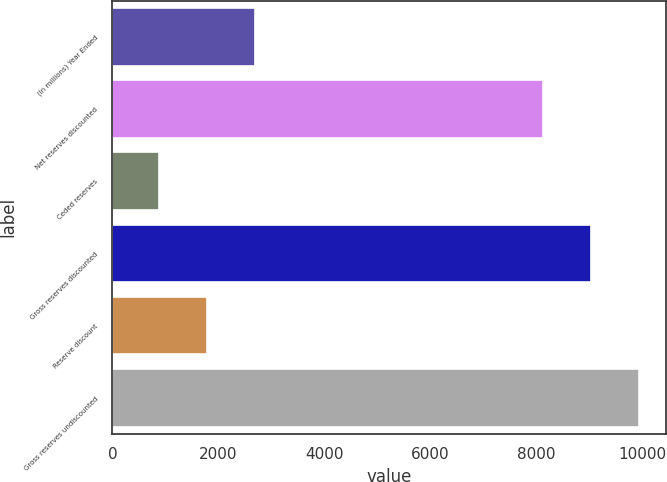Convert chart to OTSL. <chart><loc_0><loc_0><loc_500><loc_500><bar_chart><fcel>(In millions) Year Ended<fcel>Net reserves discounted<fcel>Ceded reserves<fcel>Gross reserves discounted<fcel>Reserve discount<fcel>Gross reserves undiscounted<nl><fcel>2690.4<fcel>8123<fcel>877<fcel>9029.7<fcel>1783.7<fcel>9944<nl></chart> 